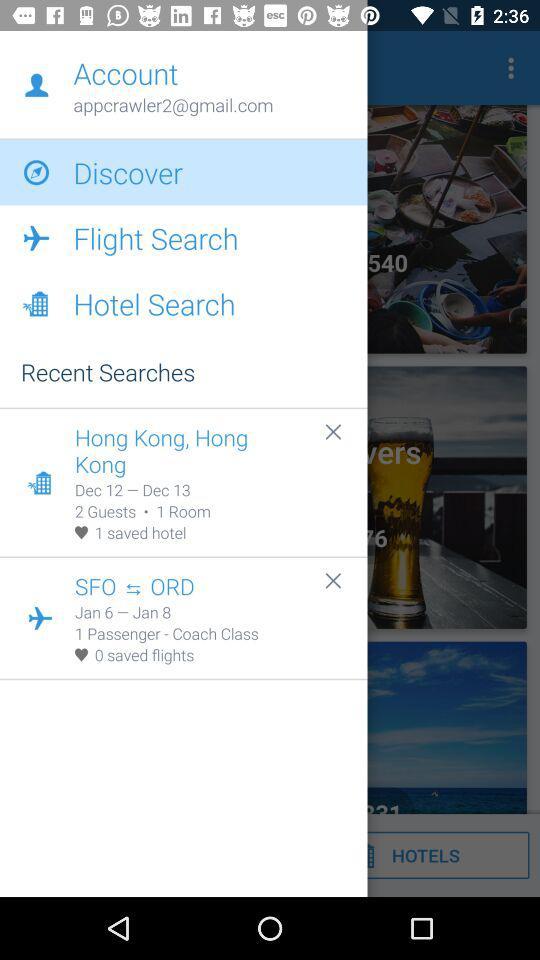How many more saved hotels are there than saved flights?
Answer the question using a single word or phrase. 1 